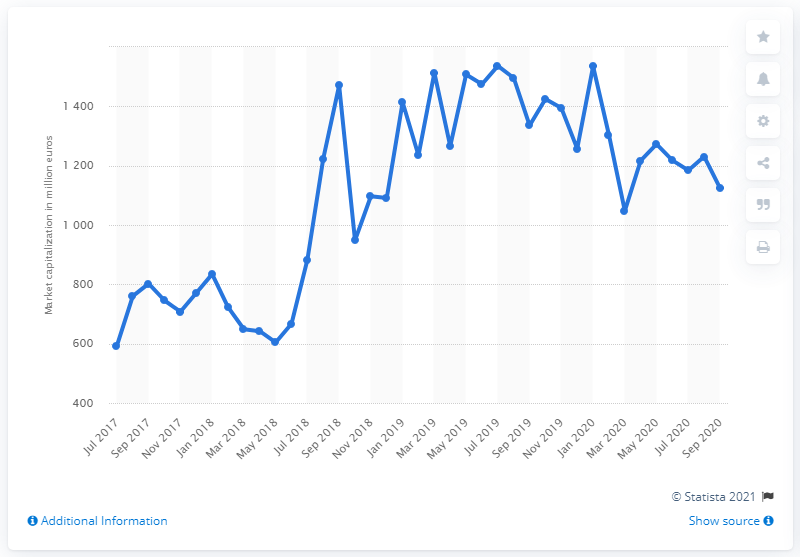Highlight a few significant elements in this photo. In January 2020, the market capitalization of the Italian football club was 1,534.88. 